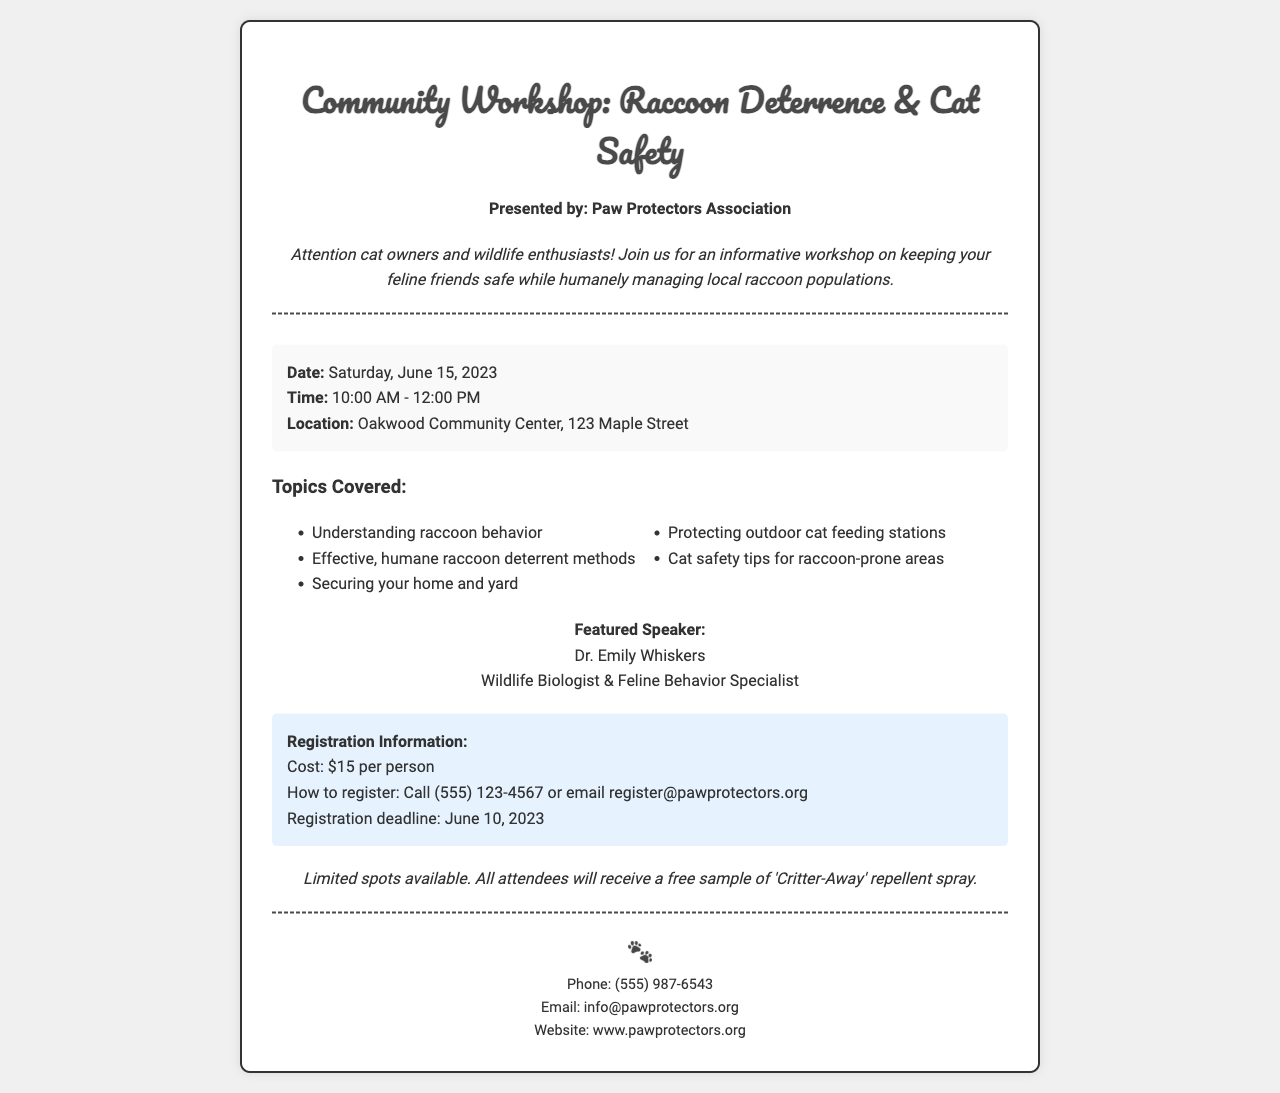what is the date of the workshop? The date of the workshop can be found in the details section of the document.
Answer: Saturday, June 15, 2023 who is the featured speaker? The featured speaker's name is mentioned in the speaker section of the document.
Answer: Dr. Emily Whiskers how much does it cost to register? The cost of registration is indicated clearly in the registration section of the document.
Answer: $15 per person what is one topic covered in the workshop? The topics covered are listed in a bullet format in the document.
Answer: Understanding raccoon behavior when is the registration deadline? The registration deadline is provided in the registration information section of the document.
Answer: June 10, 2023 where is the workshop located? The location of the workshop is found within the details section of the document.
Answer: Oakwood Community Center, 123 Maple Street how can you register for the workshop? The method to register is clearly stated in the registration section of the document.
Answer: Call (555) 123-4567 or email register@pawprotectors.org what will attendees receive? The additional information section mentions what attendees will receive.
Answer: A free sample of 'Critter-Away' repellent spray 